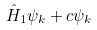<formula> <loc_0><loc_0><loc_500><loc_500>\hat { H } _ { 1 } \psi _ { k } + c \psi _ { k }</formula> 